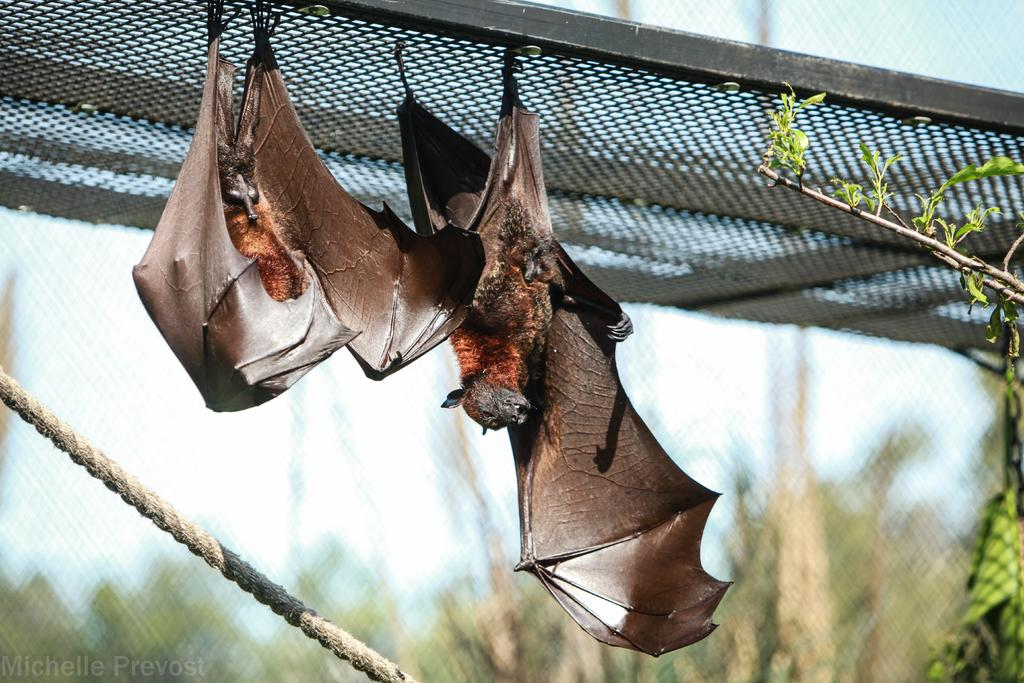How many bats can be seen in the image? There are two bats in the image. What is the rope used for in the image? The purpose of the rope is not clear from the image, but it is visible. What type of vegetation is present in the image? Leaves are present in the image. What type of material is used to create a barrier in the image? There is a mesh in the image, which is a type of barrier. How would you describe the background of the image? The background of the image is blurred. How much eggnog is being consumed by the bats in the image? There is no eggnog present in the image, and the bats are not consuming anything. What is the amount of low light in the image? The image does not provide information about the amount of low light, and the question is unrelated to the image's content. 